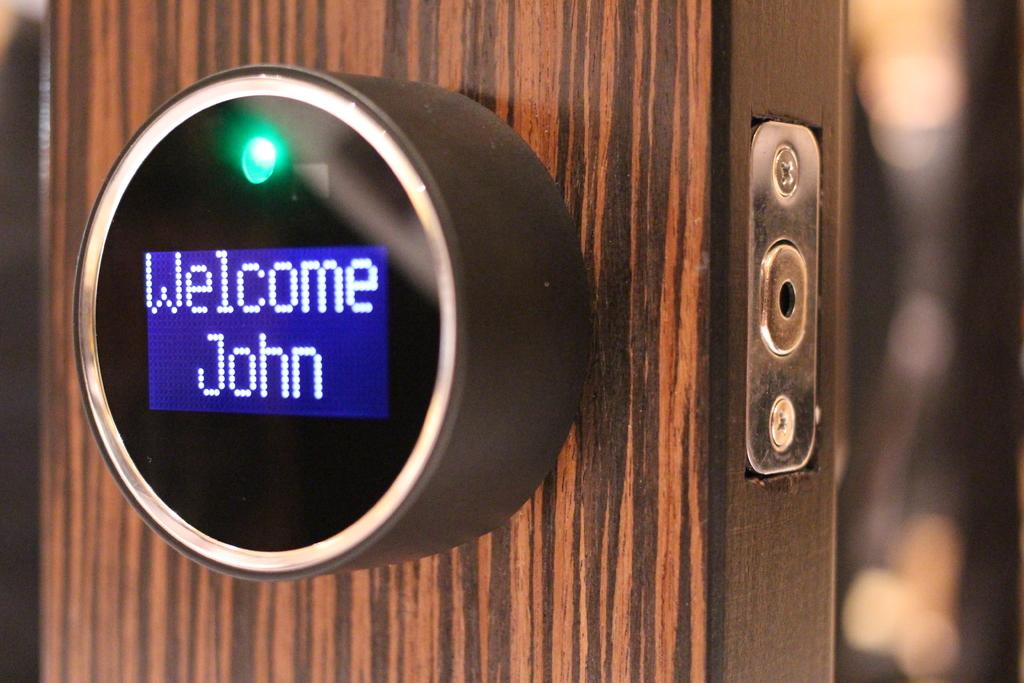<image>
Render a clear and concise summary of the photo. A lock on a door that says welcome john 